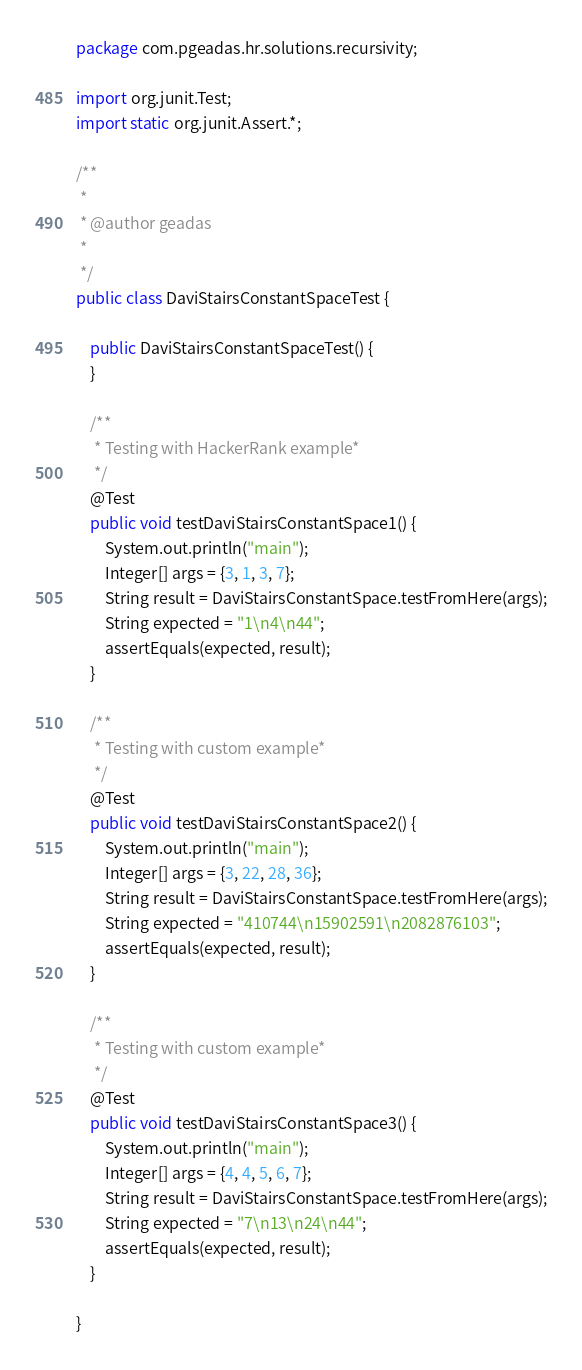<code> <loc_0><loc_0><loc_500><loc_500><_Java_>package com.pgeadas.hr.solutions.recursivity;

import org.junit.Test;
import static org.junit.Assert.*;

/**
 *
 * @author geadas
 *
 */
public class DaviStairsConstantSpaceTest {

    public DaviStairsConstantSpaceTest() {
    }

    /**
     * Testing with HackerRank example*
     */
    @Test
    public void testDaviStairsConstantSpace1() {
        System.out.println("main");
        Integer[] args = {3, 1, 3, 7};
        String result = DaviStairsConstantSpace.testFromHere(args);
        String expected = "1\n4\n44";
        assertEquals(expected, result);
    }

    /**
     * Testing with custom example*
     */
    @Test
    public void testDaviStairsConstantSpace2() {
        System.out.println("main");
        Integer[] args = {3, 22, 28, 36};
        String result = DaviStairsConstantSpace.testFromHere(args);
        String expected = "410744\n15902591\n2082876103";
        assertEquals(expected, result);
    }

    /**
     * Testing with custom example*
     */
    @Test
    public void testDaviStairsConstantSpace3() {
        System.out.println("main");
        Integer[] args = {4, 4, 5, 6, 7};
        String result = DaviStairsConstantSpace.testFromHere(args);
        String expected = "7\n13\n24\n44";
        assertEquals(expected, result);
    }

}
</code> 